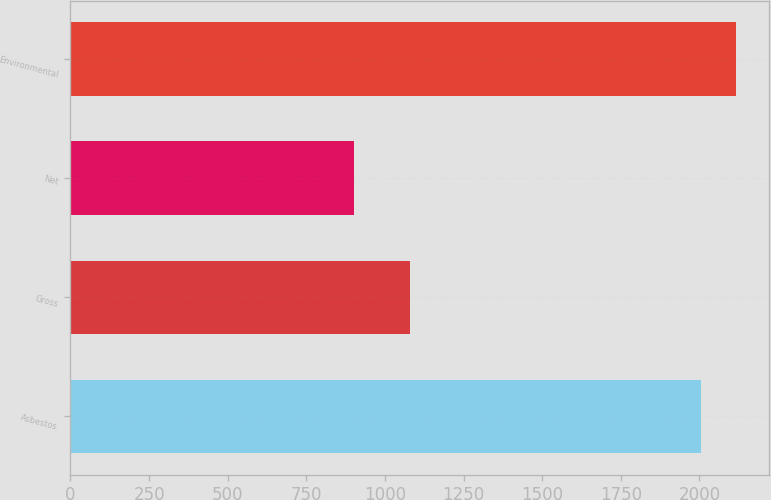Convert chart. <chart><loc_0><loc_0><loc_500><loc_500><bar_chart><fcel>Asbestos<fcel>Gross<fcel>Net<fcel>Environmental<nl><fcel>2005<fcel>1079<fcel>901<fcel>2115.4<nl></chart> 